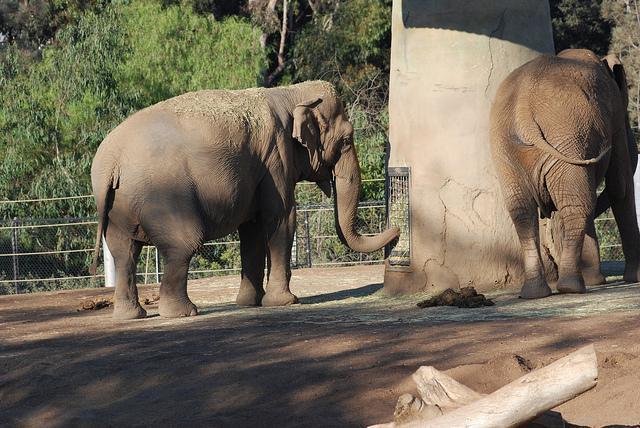How many elephants are there?
Give a very brief answer. 2. How many elephants are in the photo?
Give a very brief answer. 2. How many tusks are on each elephant?
Give a very brief answer. 0. How many elephants can be seen?
Give a very brief answer. 2. How many horses are they?
Give a very brief answer. 0. 